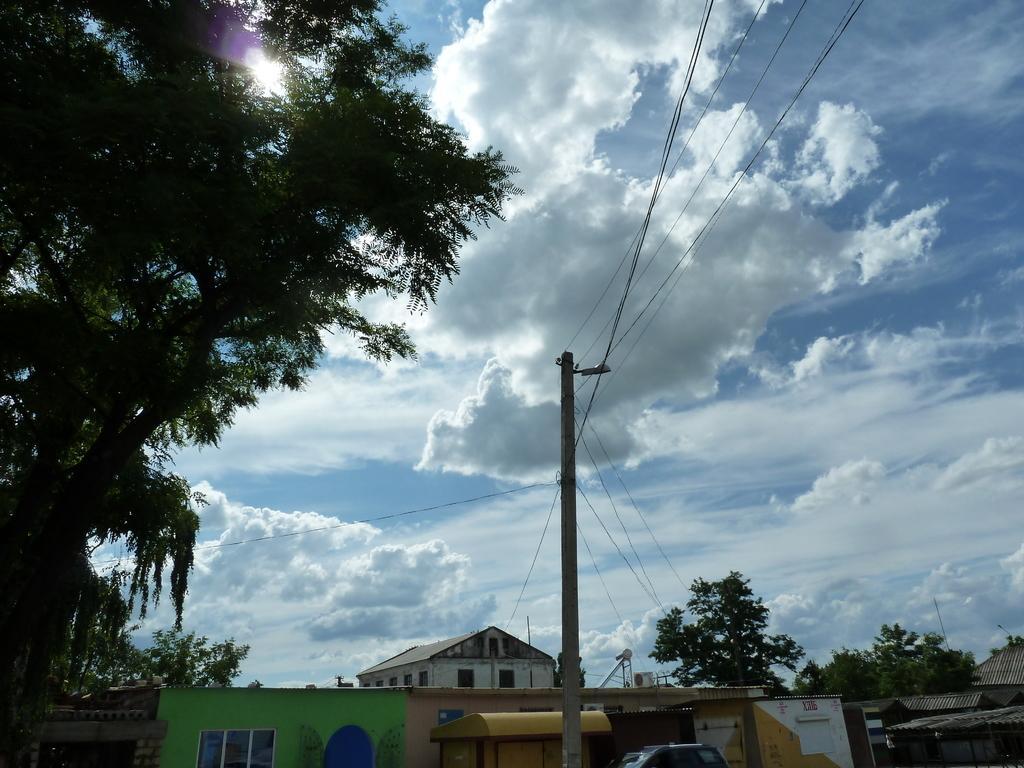In one or two sentences, can you explain what this image depicts? In this picture we can see pole, wires, light, buildings, shed, truncated vehicle and houses. On the left side of the image we can see tree. In the background of the image we can see trees and sky with clouds. 